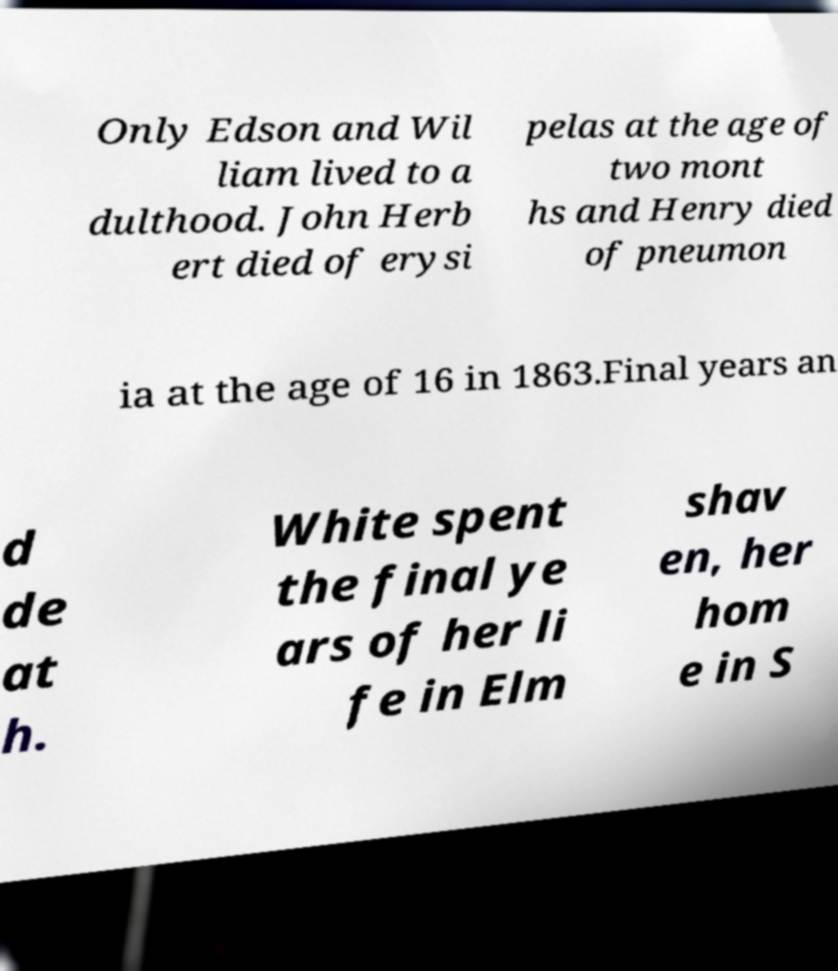There's text embedded in this image that I need extracted. Can you transcribe it verbatim? Only Edson and Wil liam lived to a dulthood. John Herb ert died of erysi pelas at the age of two mont hs and Henry died of pneumon ia at the age of 16 in 1863.Final years an d de at h. White spent the final ye ars of her li fe in Elm shav en, her hom e in S 